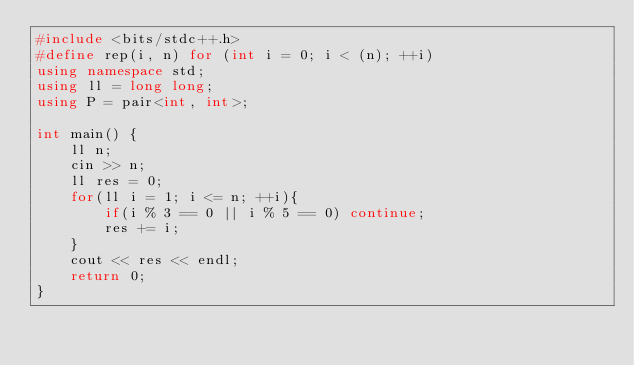<code> <loc_0><loc_0><loc_500><loc_500><_C++_>#include <bits/stdc++.h>
#define rep(i, n) for (int i = 0; i < (n); ++i)
using namespace std;
using ll = long long;
using P = pair<int, int>;

int main() {
    ll n;
    cin >> n;
    ll res = 0;
    for(ll i = 1; i <= n; ++i){
        if(i % 3 == 0 || i % 5 == 0) continue;
        res += i;
    }
    cout << res << endl;
    return 0;
}
</code> 